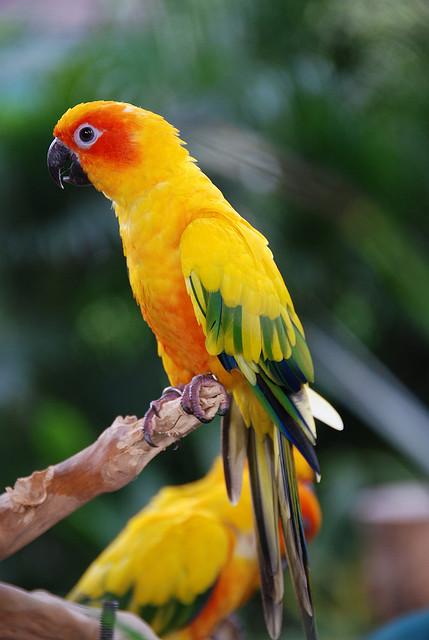What color is the ring around the eye?
Be succinct. White. What is the bird sitting on?
Short answer required. Branch. That is this bird's primary color?
Keep it brief. Yellow. What colors are on the bird?
Answer briefly. Yellow, green, orange. What type of bird is this?
Short answer required. Parrot. Is there more than one bird?
Answer briefly. Yes. How many birds are in this picture?
Answer briefly. 2. What color is the bird's breast?
Write a very short answer. Yellow. What is pictured on a tree limb?
Concise answer only. Bird. 